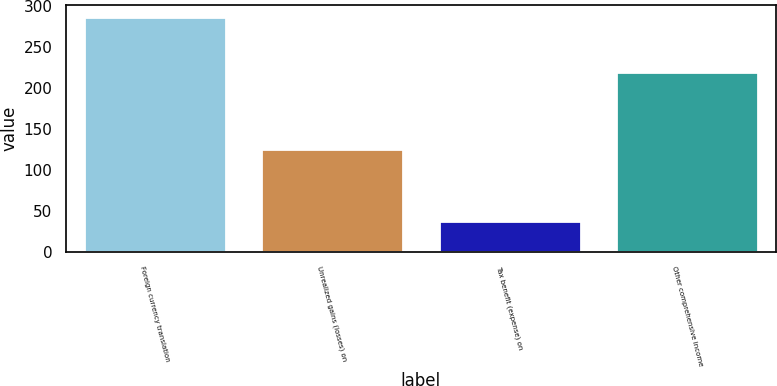<chart> <loc_0><loc_0><loc_500><loc_500><bar_chart><fcel>Foreign currency translation<fcel>Unrealized gains (losses) on<fcel>Tax benefit (expense) on<fcel>Other comprehensive income<nl><fcel>286<fcel>125<fcel>37.6<fcel>219<nl></chart> 